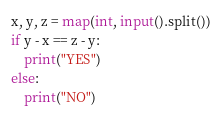Convert code to text. <code><loc_0><loc_0><loc_500><loc_500><_Python_>x, y, z = map(int, input().split())
if y - x == z - y:
    print("YES")
else:
    print("NO")
</code> 